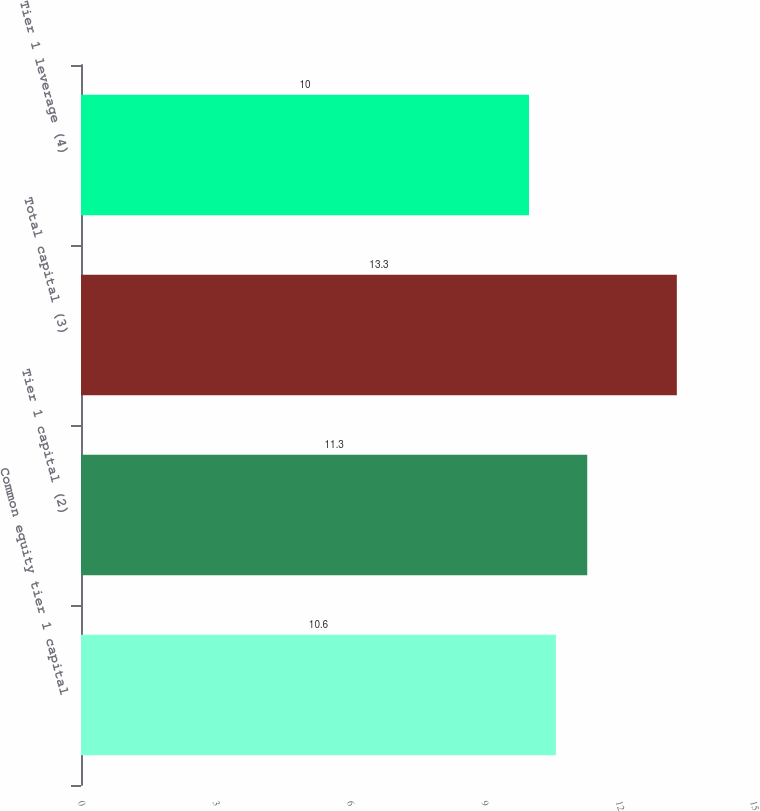Convert chart. <chart><loc_0><loc_0><loc_500><loc_500><bar_chart><fcel>Common equity tier 1 capital<fcel>Tier 1 capital (2)<fcel>Total capital (3)<fcel>Tier 1 leverage (4)<nl><fcel>10.6<fcel>11.3<fcel>13.3<fcel>10<nl></chart> 